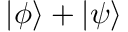<formula> <loc_0><loc_0><loc_500><loc_500>| \phi \rangle + | \psi \rangle</formula> 